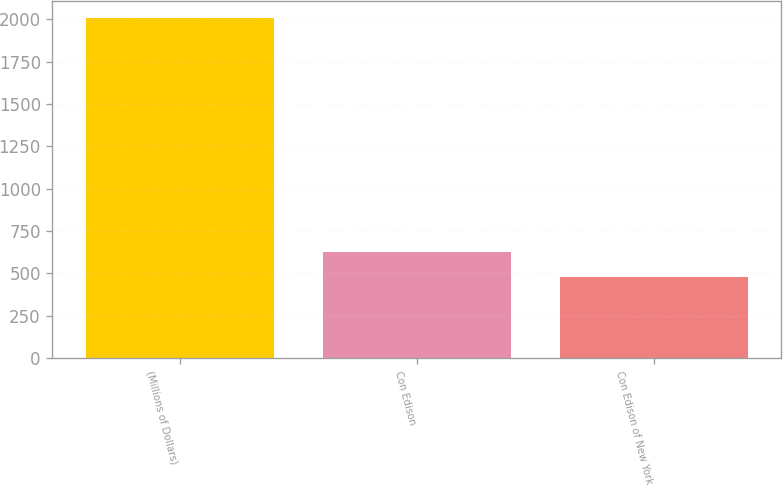Convert chart to OTSL. <chart><loc_0><loc_0><loc_500><loc_500><bar_chart><fcel>(Millions of Dollars)<fcel>Con Edison<fcel>Con Edison of New York<nl><fcel>2006<fcel>629<fcel>476<nl></chart> 